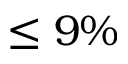Convert formula to latex. <formula><loc_0><loc_0><loc_500><loc_500>\leq 9 \%</formula> 